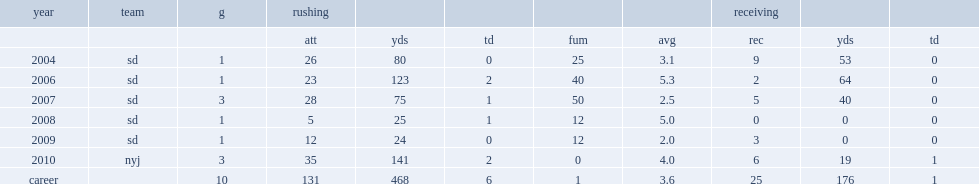How many yards did tomlinson rush for in 2006? 123.0. 